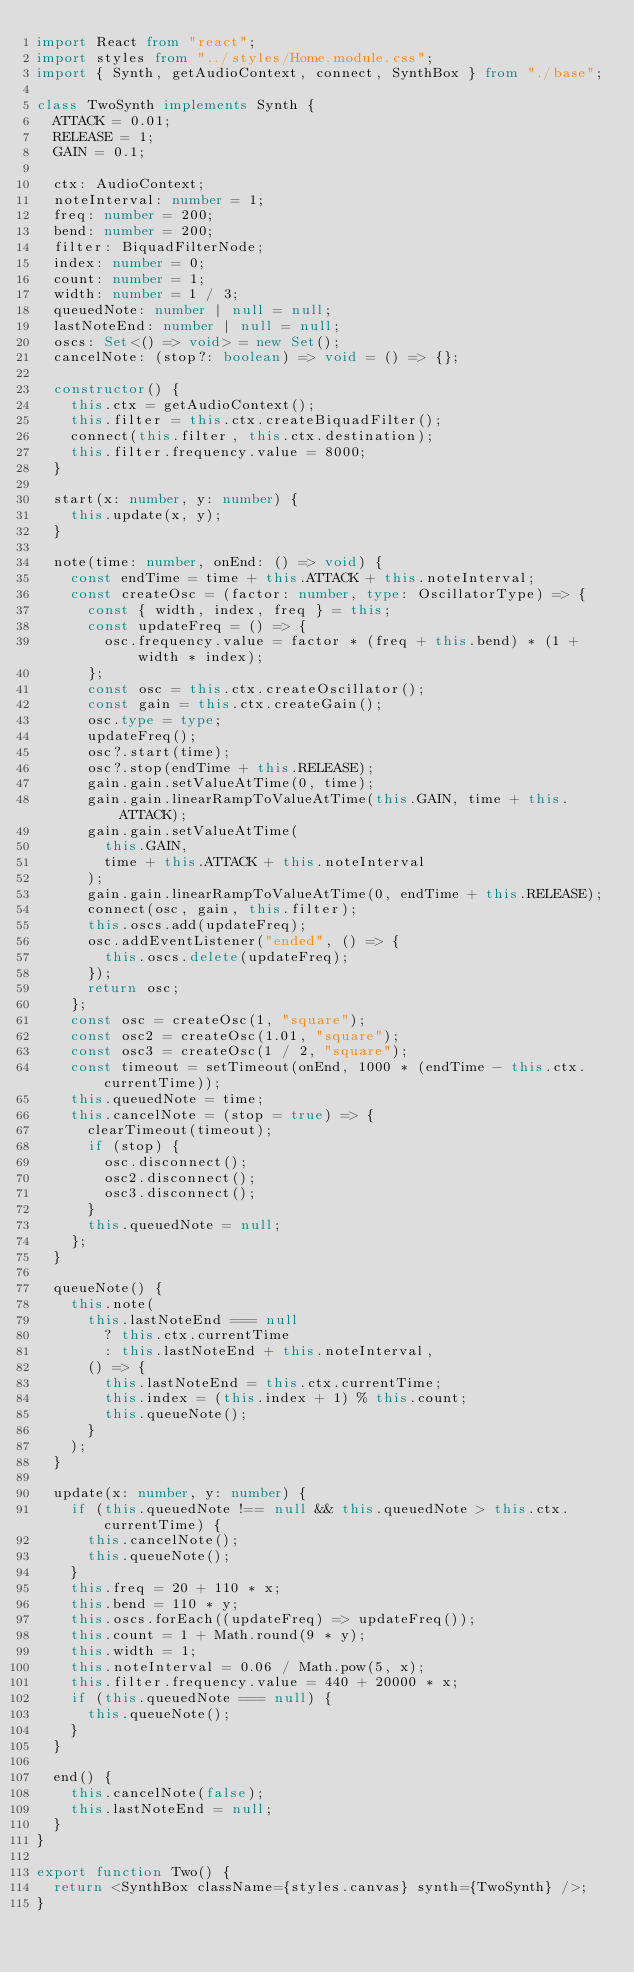Convert code to text. <code><loc_0><loc_0><loc_500><loc_500><_TypeScript_>import React from "react";
import styles from "../styles/Home.module.css";
import { Synth, getAudioContext, connect, SynthBox } from "./base";

class TwoSynth implements Synth {
  ATTACK = 0.01;
  RELEASE = 1;
  GAIN = 0.1;

  ctx: AudioContext;
  noteInterval: number = 1;
  freq: number = 200;
  bend: number = 200;
  filter: BiquadFilterNode;
  index: number = 0;
  count: number = 1;
  width: number = 1 / 3;
  queuedNote: number | null = null;
  lastNoteEnd: number | null = null;
  oscs: Set<() => void> = new Set();
  cancelNote: (stop?: boolean) => void = () => {};

  constructor() {
    this.ctx = getAudioContext();
    this.filter = this.ctx.createBiquadFilter();
    connect(this.filter, this.ctx.destination);
    this.filter.frequency.value = 8000;
  }

  start(x: number, y: number) {
    this.update(x, y);
  }

  note(time: number, onEnd: () => void) {
    const endTime = time + this.ATTACK + this.noteInterval;
    const createOsc = (factor: number, type: OscillatorType) => {
      const { width, index, freq } = this;
      const updateFreq = () => {
        osc.frequency.value = factor * (freq + this.bend) * (1 + width * index);
      };
      const osc = this.ctx.createOscillator();
      const gain = this.ctx.createGain();
      osc.type = type;
      updateFreq();
      osc?.start(time);
      osc?.stop(endTime + this.RELEASE);
      gain.gain.setValueAtTime(0, time);
      gain.gain.linearRampToValueAtTime(this.GAIN, time + this.ATTACK);
      gain.gain.setValueAtTime(
        this.GAIN,
        time + this.ATTACK + this.noteInterval
      );
      gain.gain.linearRampToValueAtTime(0, endTime + this.RELEASE);
      connect(osc, gain, this.filter);
      this.oscs.add(updateFreq);
      osc.addEventListener("ended", () => {
        this.oscs.delete(updateFreq);
      });
      return osc;
    };
    const osc = createOsc(1, "square");
    const osc2 = createOsc(1.01, "square");
    const osc3 = createOsc(1 / 2, "square");
    const timeout = setTimeout(onEnd, 1000 * (endTime - this.ctx.currentTime));
    this.queuedNote = time;
    this.cancelNote = (stop = true) => {
      clearTimeout(timeout);
      if (stop) {
        osc.disconnect();
        osc2.disconnect();
        osc3.disconnect();
      }
      this.queuedNote = null;
    };
  }

  queueNote() {
    this.note(
      this.lastNoteEnd === null
        ? this.ctx.currentTime
        : this.lastNoteEnd + this.noteInterval,
      () => {
        this.lastNoteEnd = this.ctx.currentTime;
        this.index = (this.index + 1) % this.count;
        this.queueNote();
      }
    );
  }

  update(x: number, y: number) {
    if (this.queuedNote !== null && this.queuedNote > this.ctx.currentTime) {
      this.cancelNote();
      this.queueNote();
    }
    this.freq = 20 + 110 * x;
    this.bend = 110 * y;
    this.oscs.forEach((updateFreq) => updateFreq());
    this.count = 1 + Math.round(9 * y);
    this.width = 1;
    this.noteInterval = 0.06 / Math.pow(5, x);
    this.filter.frequency.value = 440 + 20000 * x;
    if (this.queuedNote === null) {
      this.queueNote();
    }
  }

  end() {
    this.cancelNote(false);
    this.lastNoteEnd = null;
  }
}

export function Two() {
  return <SynthBox className={styles.canvas} synth={TwoSynth} />;
}
</code> 